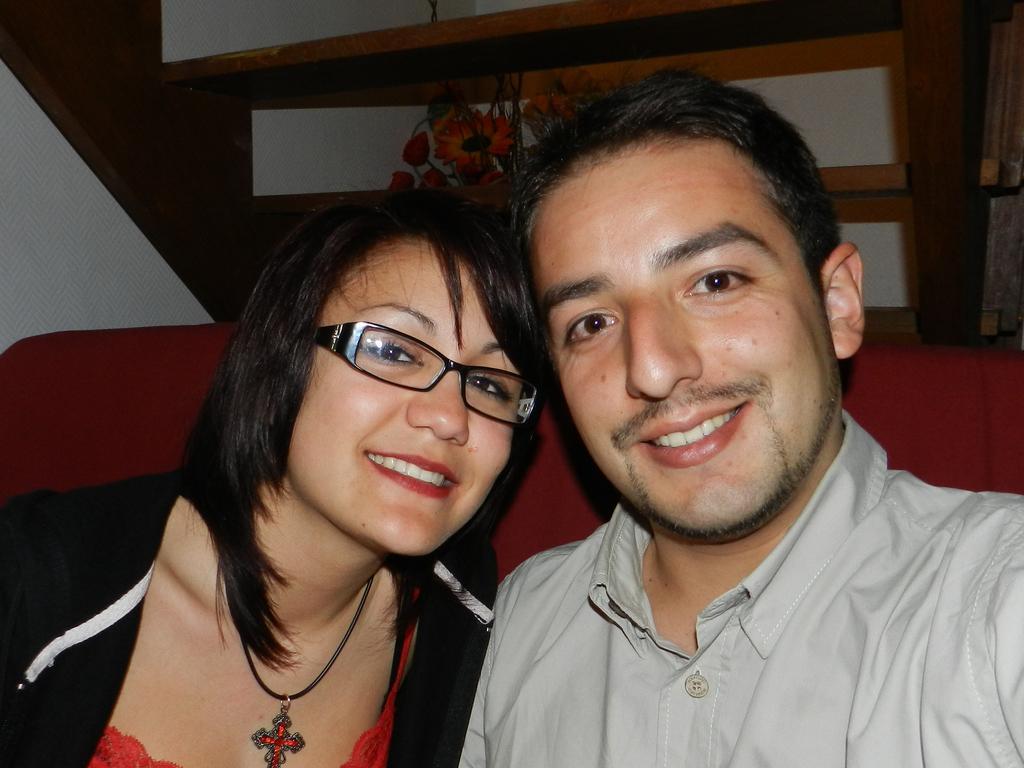In one or two sentences, can you explain what this image depicts? In this image we can see a lady and a man sitting and smiling. In the background there is a decor and we can see stairs. 